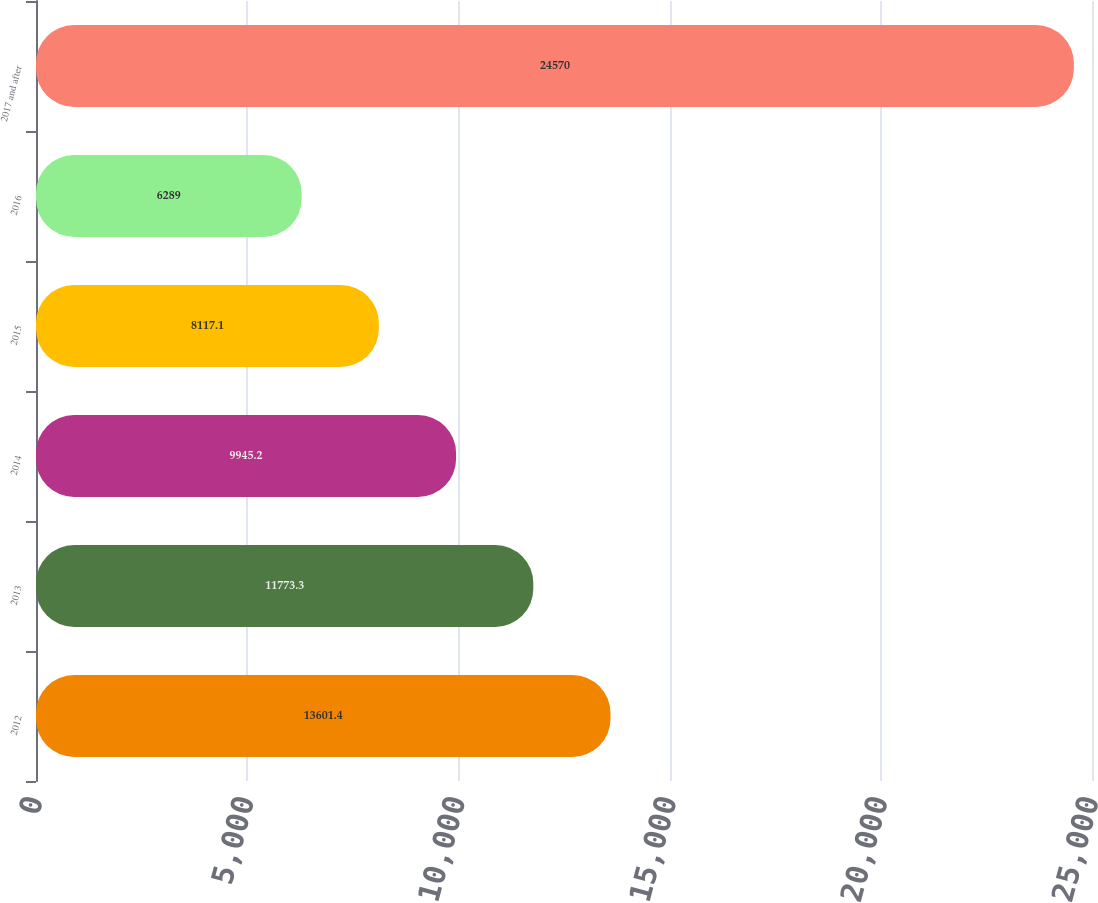Convert chart to OTSL. <chart><loc_0><loc_0><loc_500><loc_500><bar_chart><fcel>2012<fcel>2013<fcel>2014<fcel>2015<fcel>2016<fcel>2017 and after<nl><fcel>13601.4<fcel>11773.3<fcel>9945.2<fcel>8117.1<fcel>6289<fcel>24570<nl></chart> 